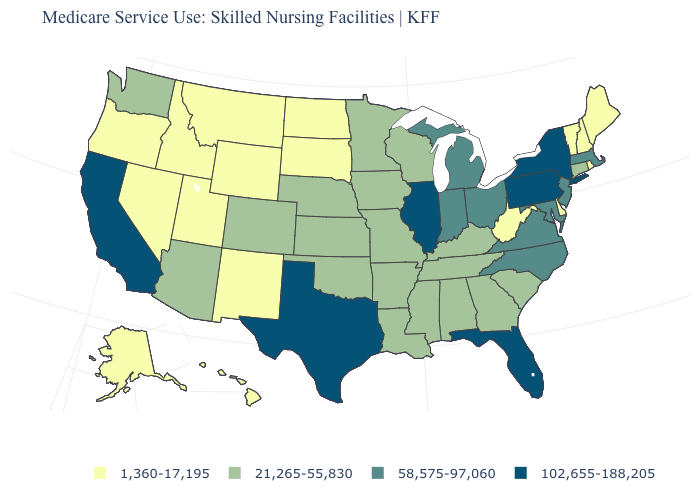What is the value of Utah?
Write a very short answer. 1,360-17,195. How many symbols are there in the legend?
Answer briefly. 4. What is the value of Alabama?
Write a very short answer. 21,265-55,830. What is the value of Iowa?
Be succinct. 21,265-55,830. Which states have the lowest value in the USA?
Keep it brief. Alaska, Delaware, Hawaii, Idaho, Maine, Montana, Nevada, New Hampshire, New Mexico, North Dakota, Oregon, Rhode Island, South Dakota, Utah, Vermont, West Virginia, Wyoming. What is the value of Maine?
Give a very brief answer. 1,360-17,195. Does Maryland have a lower value than Texas?
Give a very brief answer. Yes. Name the states that have a value in the range 58,575-97,060?
Answer briefly. Indiana, Maryland, Massachusetts, Michigan, New Jersey, North Carolina, Ohio, Virginia. What is the lowest value in the South?
Short answer required. 1,360-17,195. What is the highest value in states that border Minnesota?
Quick response, please. 21,265-55,830. Does Nebraska have the same value as Vermont?
Keep it brief. No. What is the value of Oklahoma?
Short answer required. 21,265-55,830. Among the states that border Colorado , which have the lowest value?
Quick response, please. New Mexico, Utah, Wyoming. Is the legend a continuous bar?
Quick response, please. No. Does North Dakota have the lowest value in the USA?
Answer briefly. Yes. 